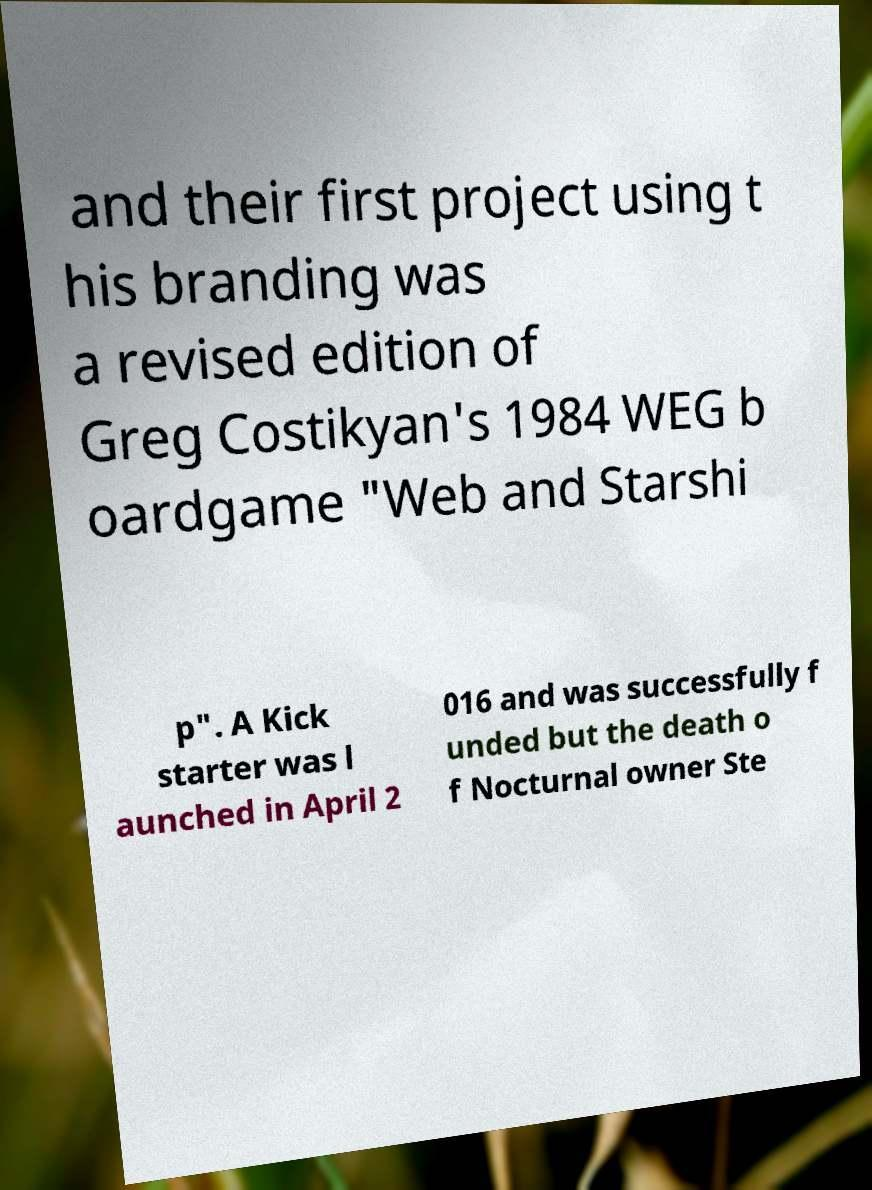Please read and relay the text visible in this image. What does it say? and their first project using t his branding was a revised edition of Greg Costikyan's 1984 WEG b oardgame "Web and Starshi p". A Kick starter was l aunched in April 2 016 and was successfully f unded but the death o f Nocturnal owner Ste 